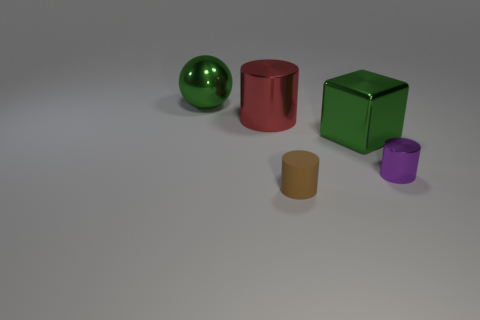There is a large metallic thing that is the same color as the large cube; what is its shape?
Make the answer very short. Sphere. How many other purple metal cylinders are the same size as the purple metal cylinder?
Ensure brevity in your answer.  0. What number of big red cylinders are in front of the red metal cylinder?
Offer a very short reply. 0. There is a green thing that is on the left side of the green object to the right of the metal sphere; what is it made of?
Make the answer very short. Metal. Is there a metal cylinder of the same color as the tiny rubber thing?
Ensure brevity in your answer.  No. There is a red object that is the same material as the green block; what is its size?
Offer a terse response. Large. Is there any other thing of the same color as the cube?
Your answer should be very brief. Yes. The metal cylinder that is to the right of the red object is what color?
Provide a succinct answer. Purple. There is a tiny cylinder that is on the left side of the tiny object that is behind the tiny brown thing; is there a big green shiny object that is right of it?
Your answer should be very brief. Yes. Is the number of purple metallic things that are to the left of the ball greater than the number of big balls?
Your answer should be compact. No. 